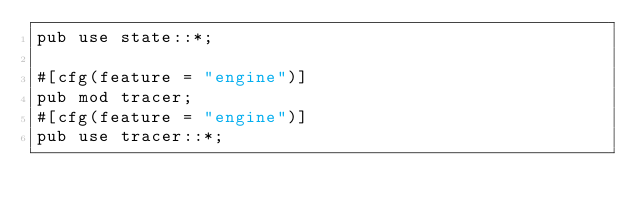Convert code to text. <code><loc_0><loc_0><loc_500><loc_500><_Rust_>pub use state::*;

#[cfg(feature = "engine")]
pub mod tracer;
#[cfg(feature = "engine")]
pub use tracer::*;
</code> 